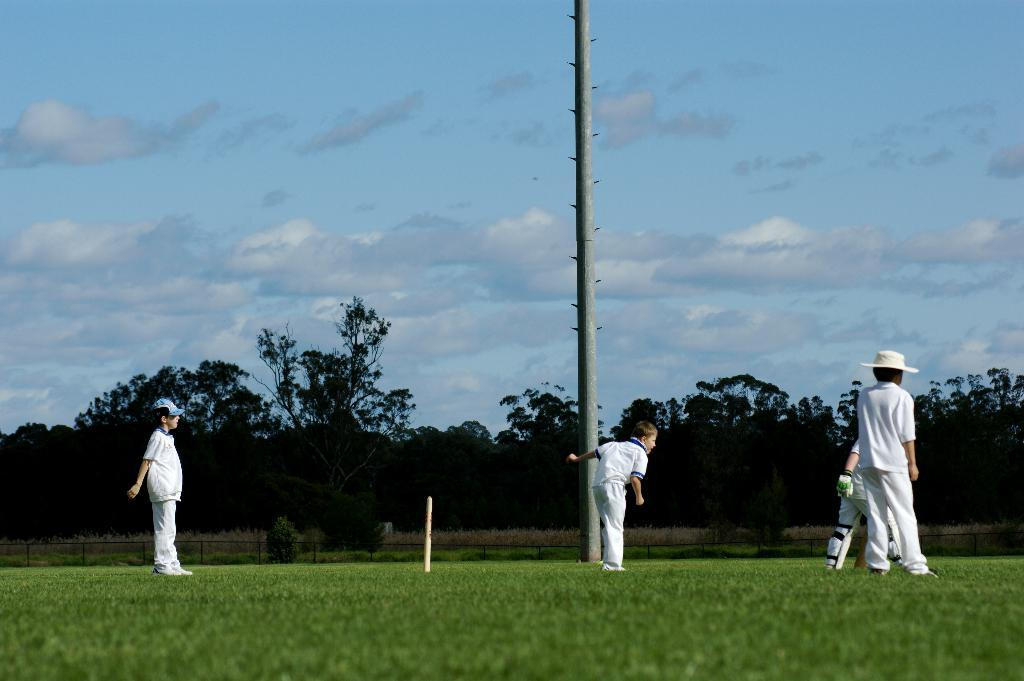What can be seen in the image? There are people standing in the image, wearing white color dresses. What is the background of the image? There are trees and fencing in the image. What is the color of the sky in the image? The sky is blue and white in color. What other objects can be seen in the image? There is a pole and a wicket in the image. What type of breakfast is being served in the image? There is no breakfast present in the image; it features people standing in white dresses, trees, fencing, a pole, and a wicket. What committee is responsible for organizing the event in the image? There is no event or committee mentioned in the image; it simply shows people standing in white dresses, trees, fencing, a pole, and a wicket. 